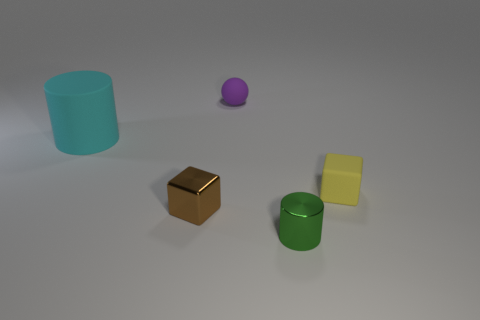What material is the yellow object that is the same shape as the brown thing?
Provide a succinct answer. Rubber. Are there any other things that have the same size as the cyan matte thing?
Your answer should be very brief. No. Are there fewer small green shiny cylinders on the left side of the brown metal cube than big cylinders that are in front of the green cylinder?
Your answer should be compact. No. What number of other things are there of the same shape as the green thing?
Offer a terse response. 1. What is the shape of the brown thing that is the same material as the green cylinder?
Offer a very short reply. Cube. There is a matte thing that is in front of the small purple thing and to the right of the tiny brown cube; what is its color?
Your answer should be very brief. Yellow. Are the small block on the right side of the small shiny cube and the large cylinder made of the same material?
Give a very brief answer. Yes. Is the number of small green cylinders on the left side of the cyan object less than the number of green things?
Offer a terse response. Yes. Are there any small cylinders that have the same material as the yellow cube?
Provide a short and direct response. No. Do the brown block and the cylinder that is on the right side of the big rubber cylinder have the same size?
Give a very brief answer. Yes. 